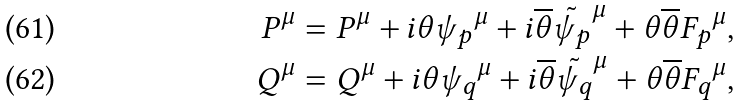<formula> <loc_0><loc_0><loc_500><loc_500>P ^ { \mu } = P ^ { \mu } + i \theta { \psi _ { p } } ^ { \mu } + i \overline { \theta } \tilde { \psi _ { p } } ^ { \mu } + \theta \overline { \theta } { F _ { p } } ^ { \mu } , \\ Q ^ { \mu } = Q ^ { \mu } + i \theta { \psi _ { q } } ^ { \mu } + i \overline { \theta } \tilde { \psi _ { q } } ^ { \mu } + \theta \overline { \theta } { F _ { q } } ^ { \mu } ,</formula> 